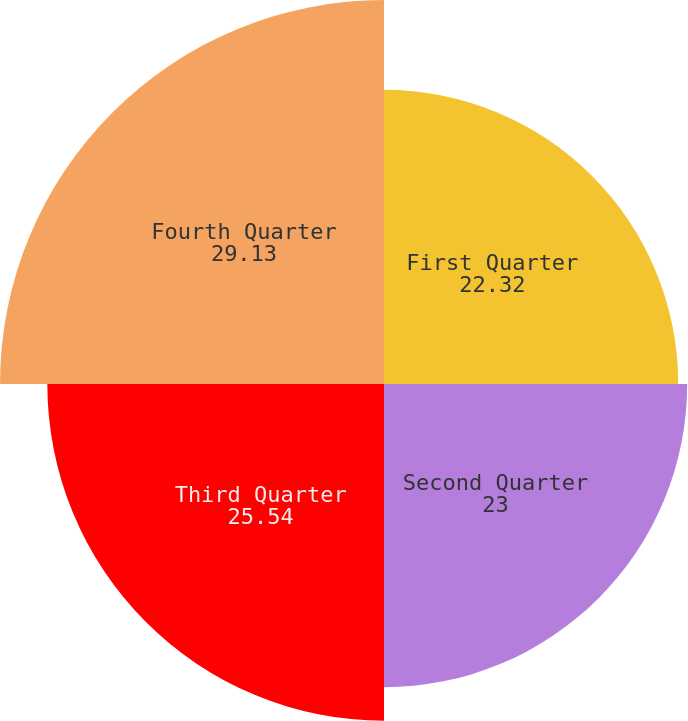Convert chart. <chart><loc_0><loc_0><loc_500><loc_500><pie_chart><fcel>First Quarter<fcel>Second Quarter<fcel>Third Quarter<fcel>Fourth Quarter<nl><fcel>22.32%<fcel>23.0%<fcel>25.54%<fcel>29.13%<nl></chart> 